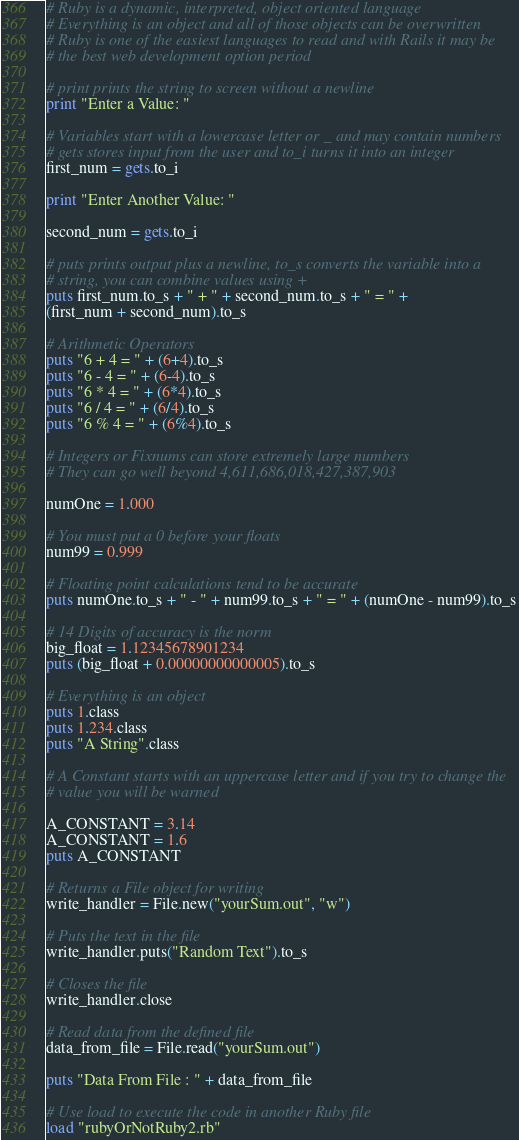Convert code to text. <code><loc_0><loc_0><loc_500><loc_500><_Ruby_># Ruby is a dynamic, interpreted, object oriented language
# Everything is an object and all of those objects can be overwritten
# Ruby is one of the easiest languages to read and with Rails it may be
# the best web development option period

# print prints the string to screen without a newline
print "Enter a Value: "

# Variables start with a lowercase letter or _ and may contain numbers
# gets stores input from the user and to_i turns it into an integer
first_num = gets.to_i

print "Enter Another Value: "

second_num = gets.to_i

# puts prints output plus a newline, to_s converts the variable into a
# string, you can combine values using +
puts first_num.to_s + " + " + second_num.to_s + " = " +
(first_num + second_num).to_s

# Arithmetic Operators
puts "6 + 4 = " + (6+4).to_s
puts "6 - 4 = " + (6-4).to_s
puts "6 * 4 = " + (6*4).to_s
puts "6 / 4 = " + (6/4).to_s
puts "6 % 4 = " + (6%4).to_s

# Integers or Fixnums can store extremely large numbers
# They can go well beyond 4,611,686,018,427,387,903

numOne = 1.000

# You must put a 0 before your floats
num99 = 0.999

# Floating point calculations tend to be accurate
puts numOne.to_s + " - " + num99.to_s + " = " + (numOne - num99).to_s

# 14 Digits of accuracy is the norm
big_float = 1.12345678901234
puts (big_float + 0.00000000000005).to_s

# Everything is an object
puts 1.class
puts 1.234.class
puts "A String".class

# A Constant starts with an uppercase letter and if you try to change the
# value you will be warned

A_CONSTANT = 3.14
A_CONSTANT = 1.6
puts A_CONSTANT

# Returns a File object for writing
write_handler = File.new("yourSum.out", "w")

# Puts the text in the file
write_handler.puts("Random Text").to_s

# Closes the file
write_handler.close

# Read data from the defined file
data_from_file = File.read("yourSum.out")

puts "Data From File : " + data_from_file

# Use load to execute the code in another Ruby file
load "rubyOrNotRuby2.rb"</code> 